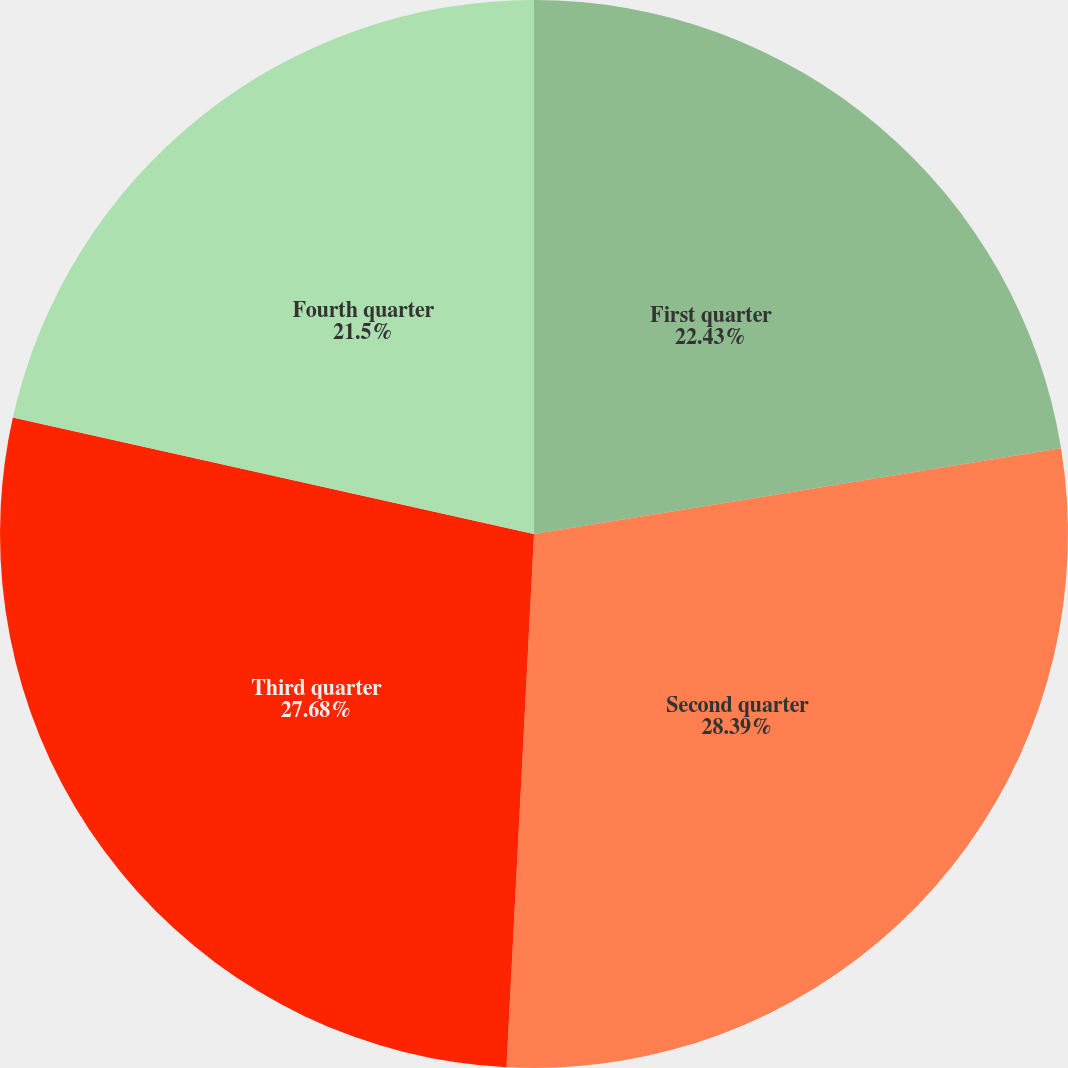Convert chart to OTSL. <chart><loc_0><loc_0><loc_500><loc_500><pie_chart><fcel>First quarter<fcel>Second quarter<fcel>Third quarter<fcel>Fourth quarter<nl><fcel>22.43%<fcel>28.39%<fcel>27.68%<fcel>21.5%<nl></chart> 